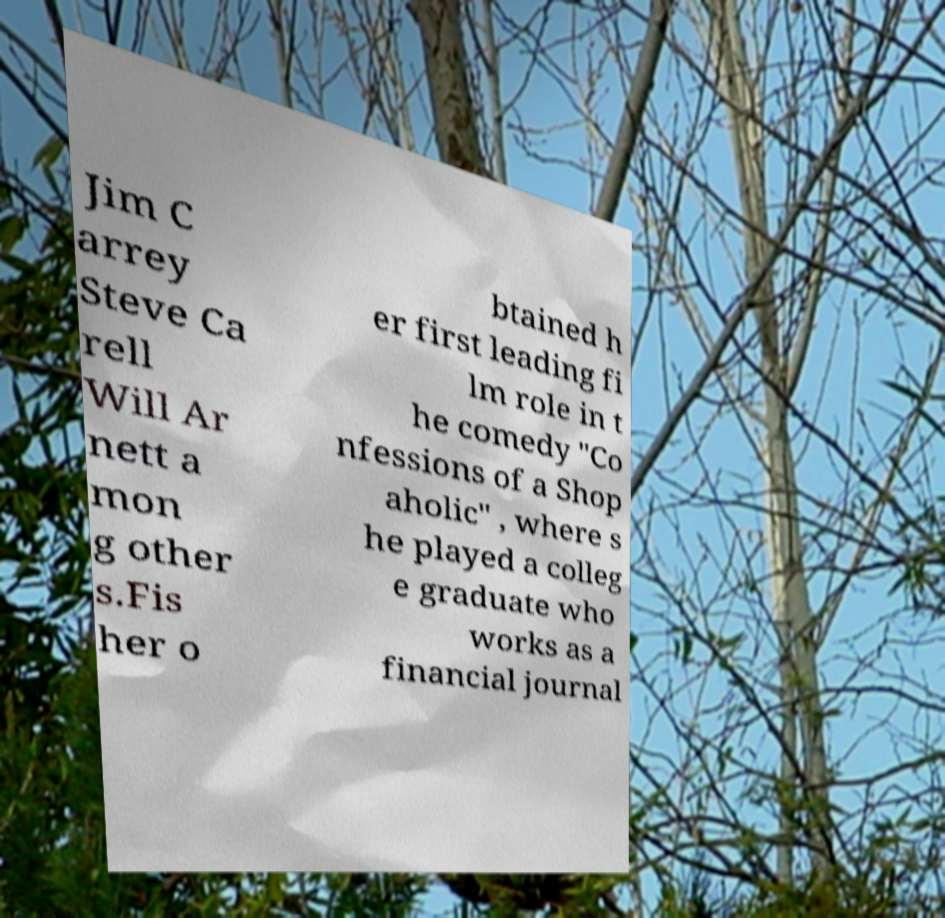Could you assist in decoding the text presented in this image and type it out clearly? Jim C arrey Steve Ca rell Will Ar nett a mon g other s.Fis her o btained h er first leading fi lm role in t he comedy "Co nfessions of a Shop aholic" , where s he played a colleg e graduate who works as a financial journal 